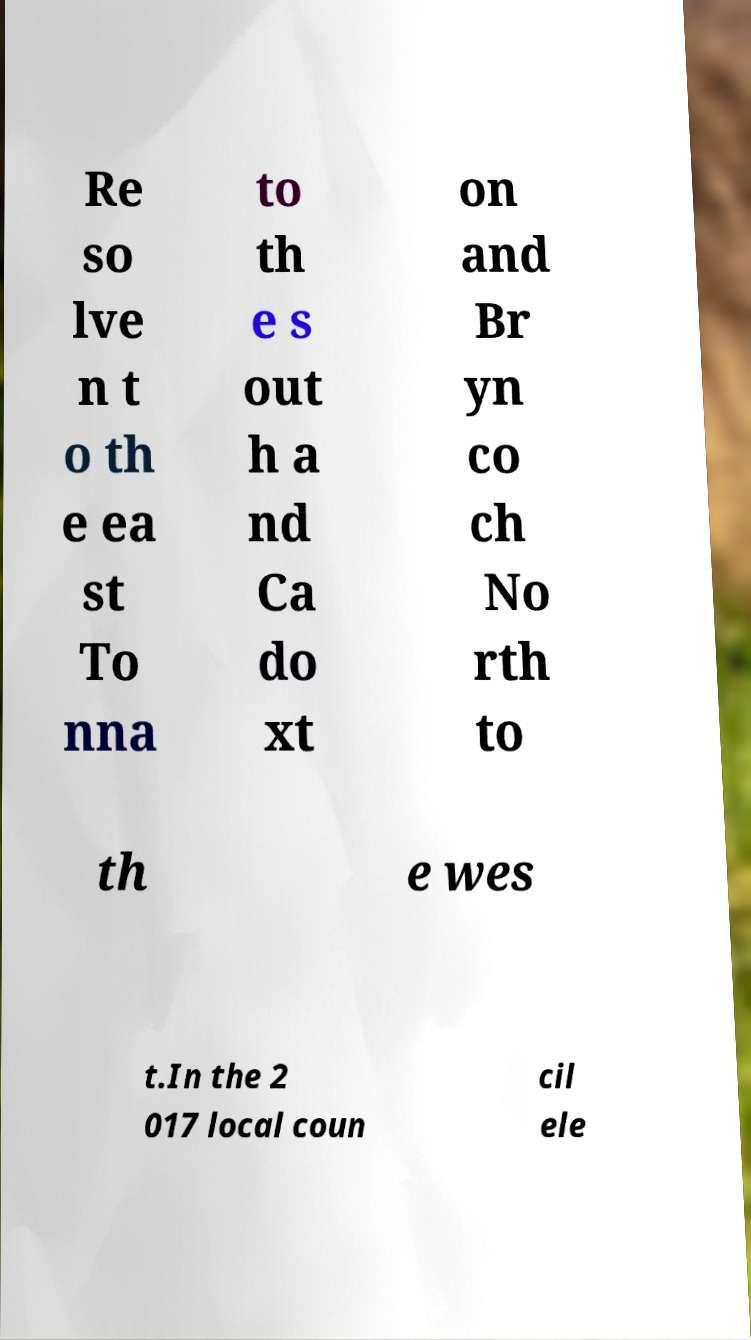Could you assist in decoding the text presented in this image and type it out clearly? Re so lve n t o th e ea st To nna to th e s out h a nd Ca do xt on and Br yn co ch No rth to th e wes t.In the 2 017 local coun cil ele 